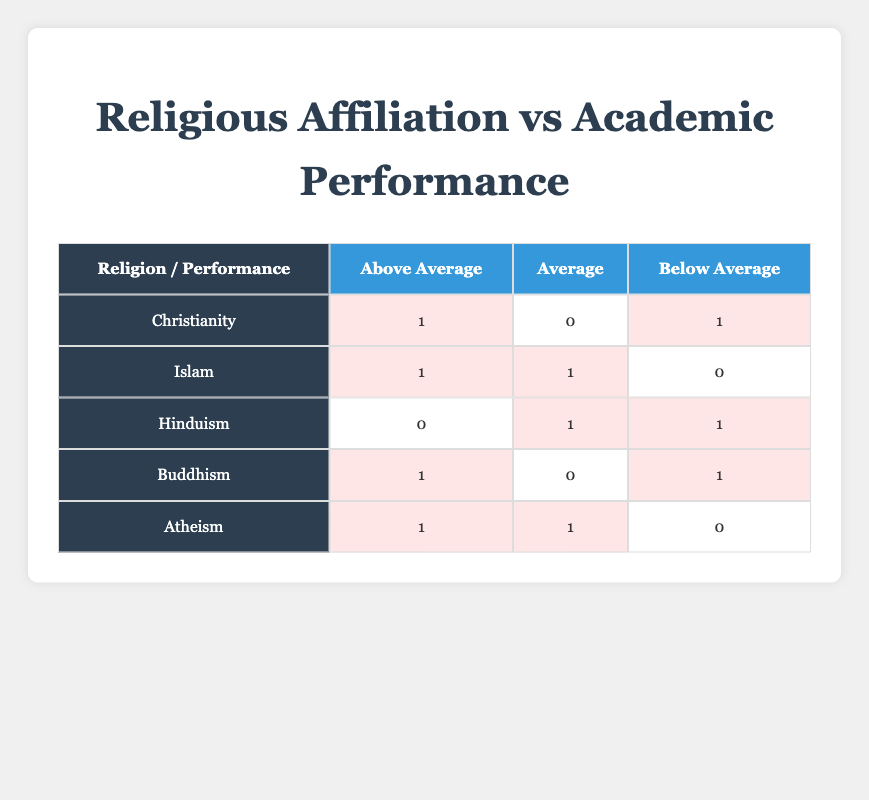What is the count of students from Buddhism that have an Above Average academic performance? According to the table, Buddhism has 1 student with an Above Average performance. We can see from the row for Buddhism that it shows a count of 1 in the Above Average column.
Answer: 1 How many students practicing Atheism achieved Below Average academic performance? Looking at the Atheism row in the table, there are 0 students noted in the Below Average column, indicating that no Atheist students fall into that performance category.
Answer: 0 What is the total number of students who have an Above Average academic performance? We can find the total count of Above Average students by adding together the counts from each religion: Christianity (1) + Islam (1) + Hinduism (0) + Buddhism (1) + Atheism (1) = 4. Therefore, the total number of students with Above Average performance is 4.
Answer: 4 Is it true that all students who identify as Hinduism have Average or Below Average academic performance? In the table, under the Hinduism row, we see that there is 1 student listed in Average and 1 student listed in Below Average, with no students in the Above Average category. Therefore, the statement is true.
Answer: Yes Which group has the highest count of Below Average academic performance? To determine this, we compare the counts of Below Average students from each religion: Christianity (1), Islam (0), Hinduism (1), Buddhism (1), and Atheism (0). Hinduism, Buddhism, and Christianity all have 1 student in this category. Therefore, there is no single group with a higher count; they are tied.
Answer: Tie among Hinduism, Buddhism, and Christianity 